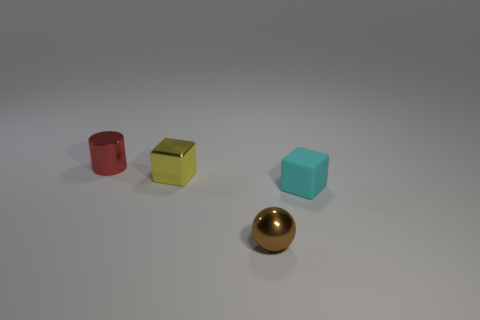How many other things are the same size as the brown ball?
Your answer should be very brief. 3. What is the shape of the small matte thing to the right of the small metallic ball that is in front of the object right of the tiny metal ball?
Ensure brevity in your answer.  Cube. What number of yellow objects are small blocks or small matte objects?
Your answer should be very brief. 1. How many cyan rubber things are on the left side of the object that is right of the small sphere?
Provide a succinct answer. 0. Is there any other thing of the same color as the small ball?
Your response must be concise. No. There is a tiny yellow thing that is made of the same material as the small brown object; what is its shape?
Your answer should be compact. Cube. Does the small block that is behind the cyan rubber block have the same material as the object in front of the tiny cyan cube?
Your response must be concise. Yes. How many objects are red matte things or small objects in front of the tiny metal block?
Provide a succinct answer. 2. Is there anything else that is the same material as the yellow block?
Your answer should be very brief. Yes. What material is the cylinder?
Provide a short and direct response. Metal. 